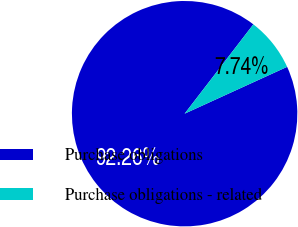Convert chart. <chart><loc_0><loc_0><loc_500><loc_500><pie_chart><fcel>Purchase obligations<fcel>Purchase obligations - related<nl><fcel>92.26%<fcel>7.74%<nl></chart> 